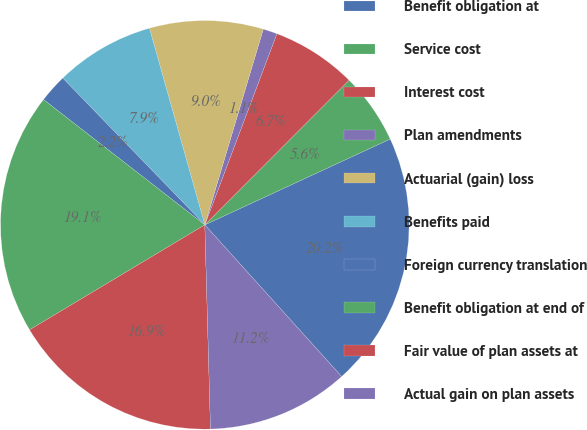Convert chart to OTSL. <chart><loc_0><loc_0><loc_500><loc_500><pie_chart><fcel>Benefit obligation at<fcel>Service cost<fcel>Interest cost<fcel>Plan amendments<fcel>Actuarial (gain) loss<fcel>Benefits paid<fcel>Foreign currency translation<fcel>Benefit obligation at end of<fcel>Fair value of plan assets at<fcel>Actual gain on plan assets<nl><fcel>20.22%<fcel>5.62%<fcel>6.74%<fcel>1.12%<fcel>8.99%<fcel>7.87%<fcel>2.25%<fcel>19.1%<fcel>16.85%<fcel>11.24%<nl></chart> 